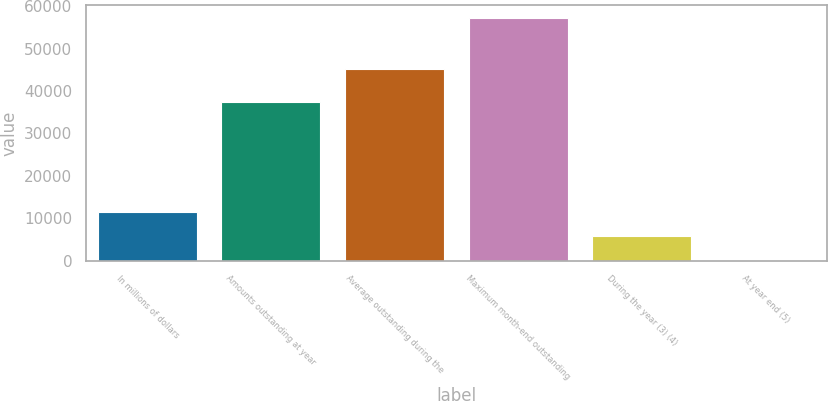Convert chart to OTSL. <chart><loc_0><loc_0><loc_500><loc_500><bar_chart><fcel>In millions of dollars<fcel>Amounts outstanding at year<fcel>Average outstanding during the<fcel>Maximum month-end outstanding<fcel>During the year (3) (4)<fcel>At year end (5)<nl><fcel>11464.5<fcel>37343<fcel>45204<fcel>57303<fcel>5734.73<fcel>4.92<nl></chart> 